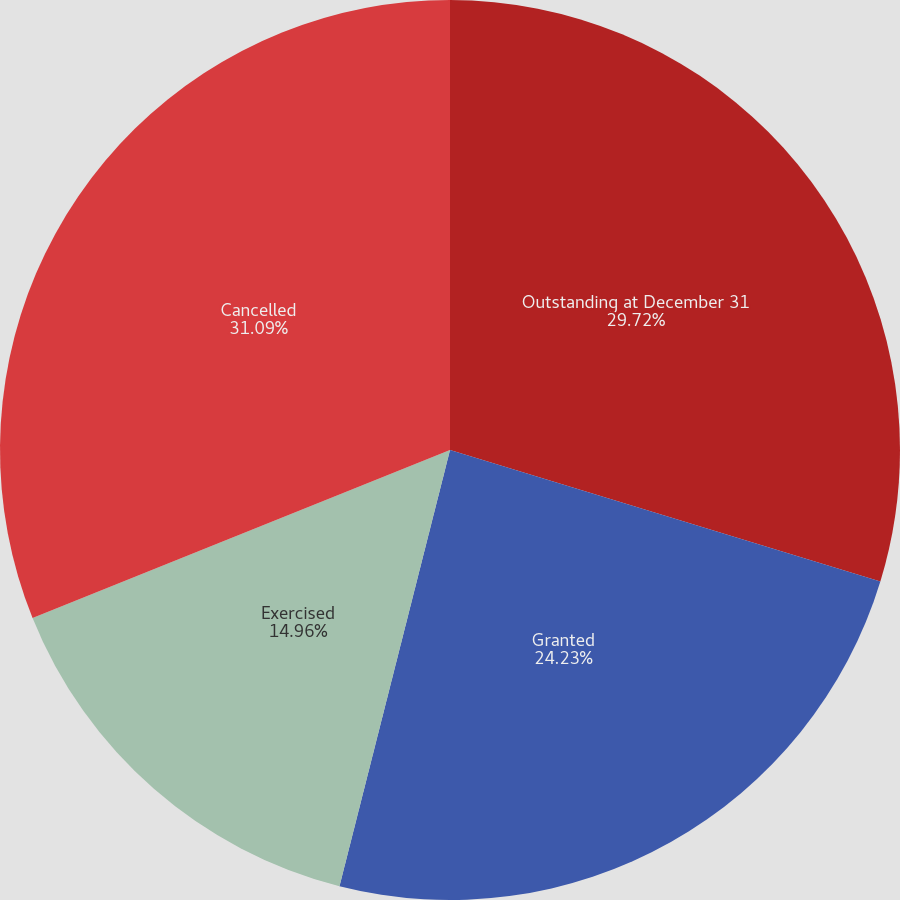Convert chart. <chart><loc_0><loc_0><loc_500><loc_500><pie_chart><fcel>Outstanding at December 31<fcel>Granted<fcel>Exercised<fcel>Cancelled<nl><fcel>29.72%<fcel>24.23%<fcel>14.96%<fcel>31.09%<nl></chart> 